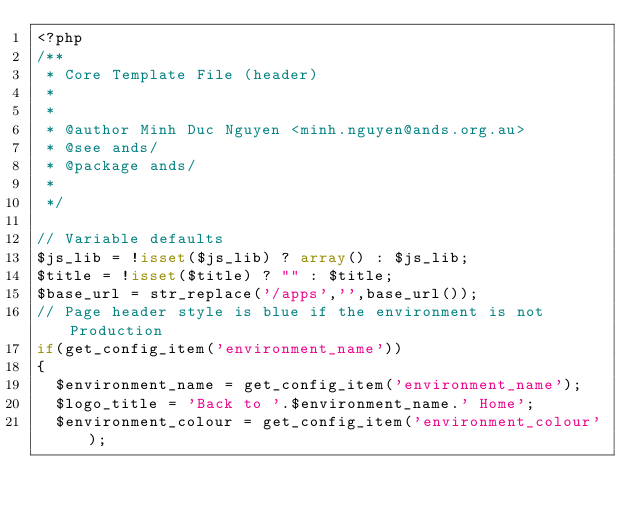Convert code to text. <code><loc_0><loc_0><loc_500><loc_500><_PHP_><?php
/**
 * Core Template File (header)
 * 
 * 
 * @author Minh Duc Nguyen <minh.nguyen@ands.org.au>
 * @see ands/
 * @package ands/
 * 
 */

// Variable defaults
$js_lib = !isset($js_lib) ? array() : $js_lib;
$title = !isset($title) ? "" : $title;
$base_url = str_replace('/apps','',base_url());
// Page header style is blue if the environment is not Production
if(get_config_item('environment_name'))
{
  $environment_name = get_config_item('environment_name');
  $logo_title = 'Back to '.$environment_name.' Home';
  $environment_colour = get_config_item('environment_colour');</code> 